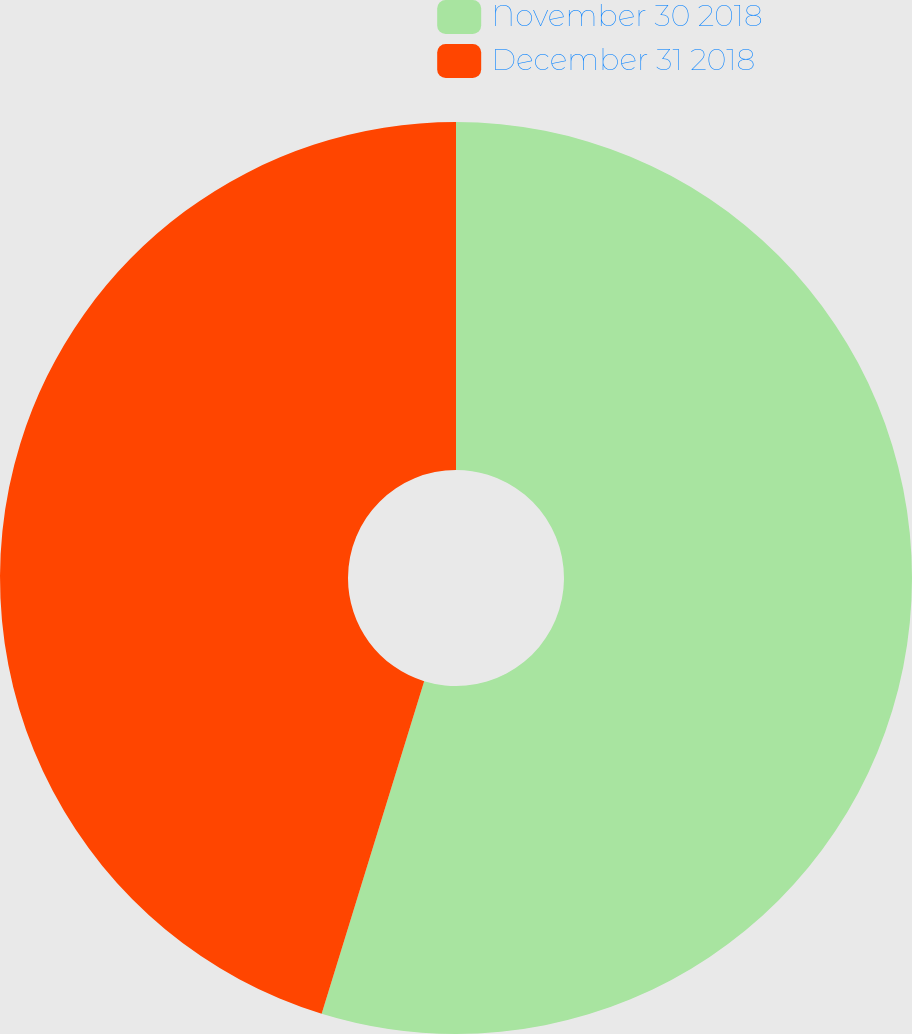Convert chart. <chart><loc_0><loc_0><loc_500><loc_500><pie_chart><fcel>November 30 2018<fcel>December 31 2018<nl><fcel>54.76%<fcel>45.24%<nl></chart> 